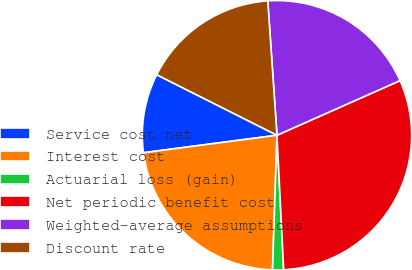Convert chart to OTSL. <chart><loc_0><loc_0><loc_500><loc_500><pie_chart><fcel>Service cost net<fcel>Interest cost<fcel>Actuarial loss (gain)<fcel>Net periodic benefit cost<fcel>Weighted-average assumptions<fcel>Discount rate<nl><fcel>9.5%<fcel>22.4%<fcel>1.32%<fcel>30.86%<fcel>19.44%<fcel>16.49%<nl></chart> 